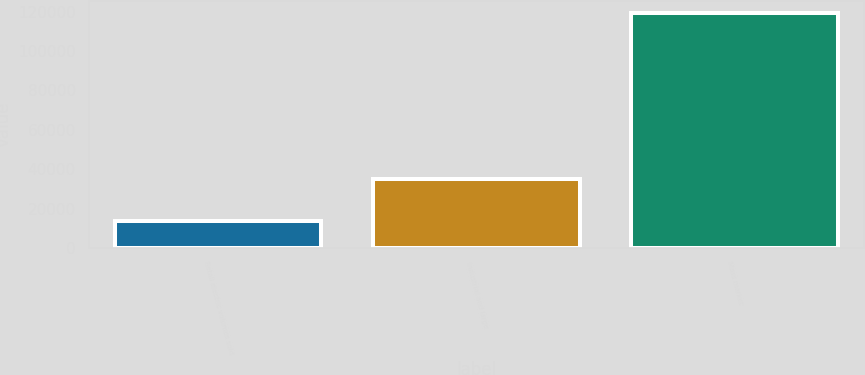Convert chart to OTSL. <chart><loc_0><loc_0><loc_500><loc_500><bar_chart><fcel>Retail electric volumes sold<fcel>Industrial and large<fcel>Mass market<nl><fcel>13840<fcel>35043<fcel>119276<nl></chart> 